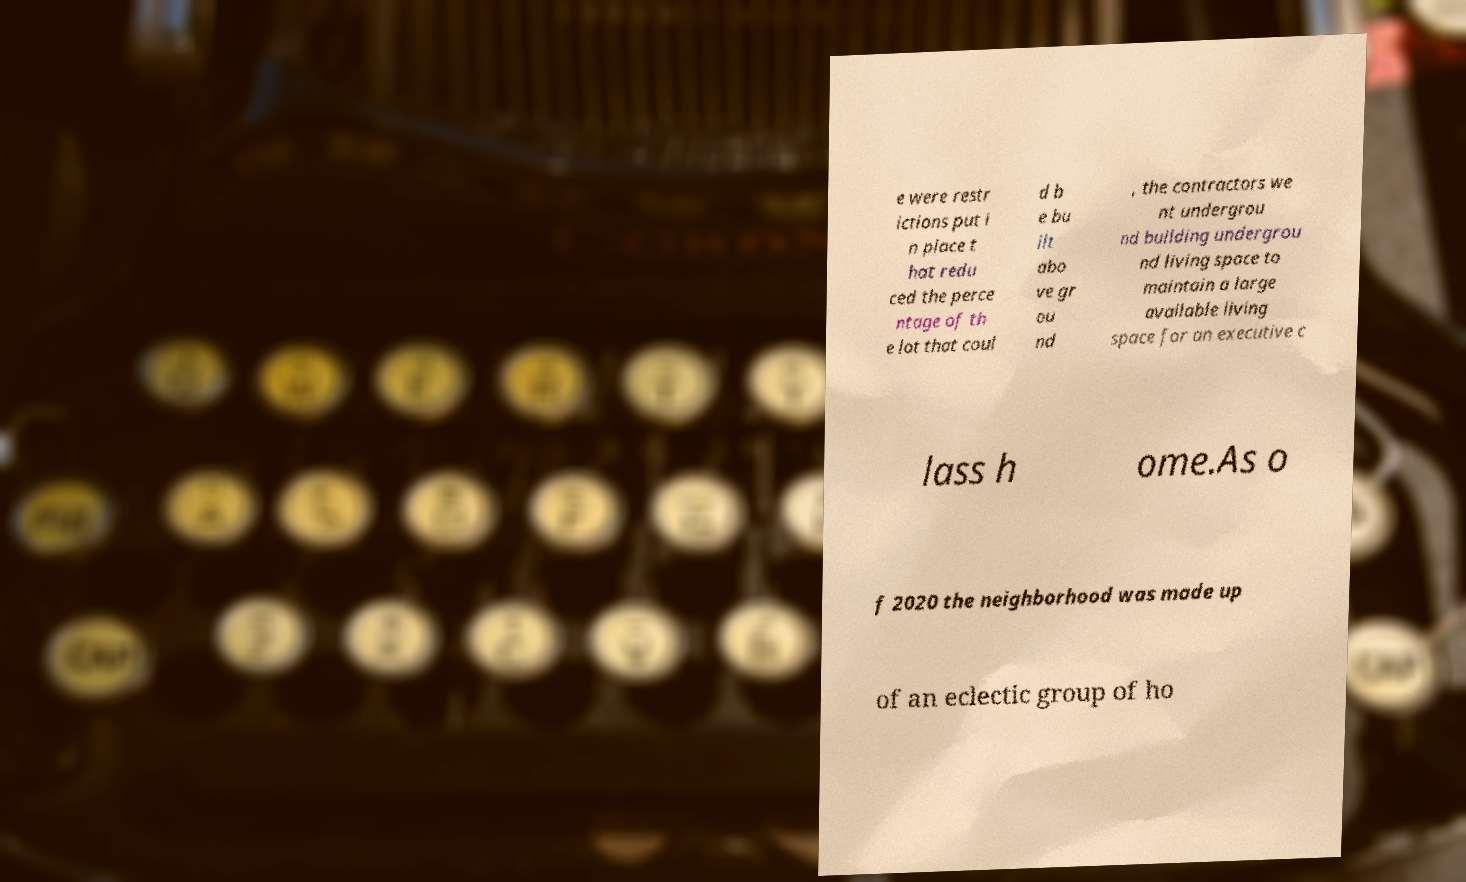Can you read and provide the text displayed in the image?This photo seems to have some interesting text. Can you extract and type it out for me? e were restr ictions put i n place t hat redu ced the perce ntage of th e lot that coul d b e bu ilt abo ve gr ou nd , the contractors we nt undergrou nd building undergrou nd living space to maintain a large available living space for an executive c lass h ome.As o f 2020 the neighborhood was made up of an eclectic group of ho 